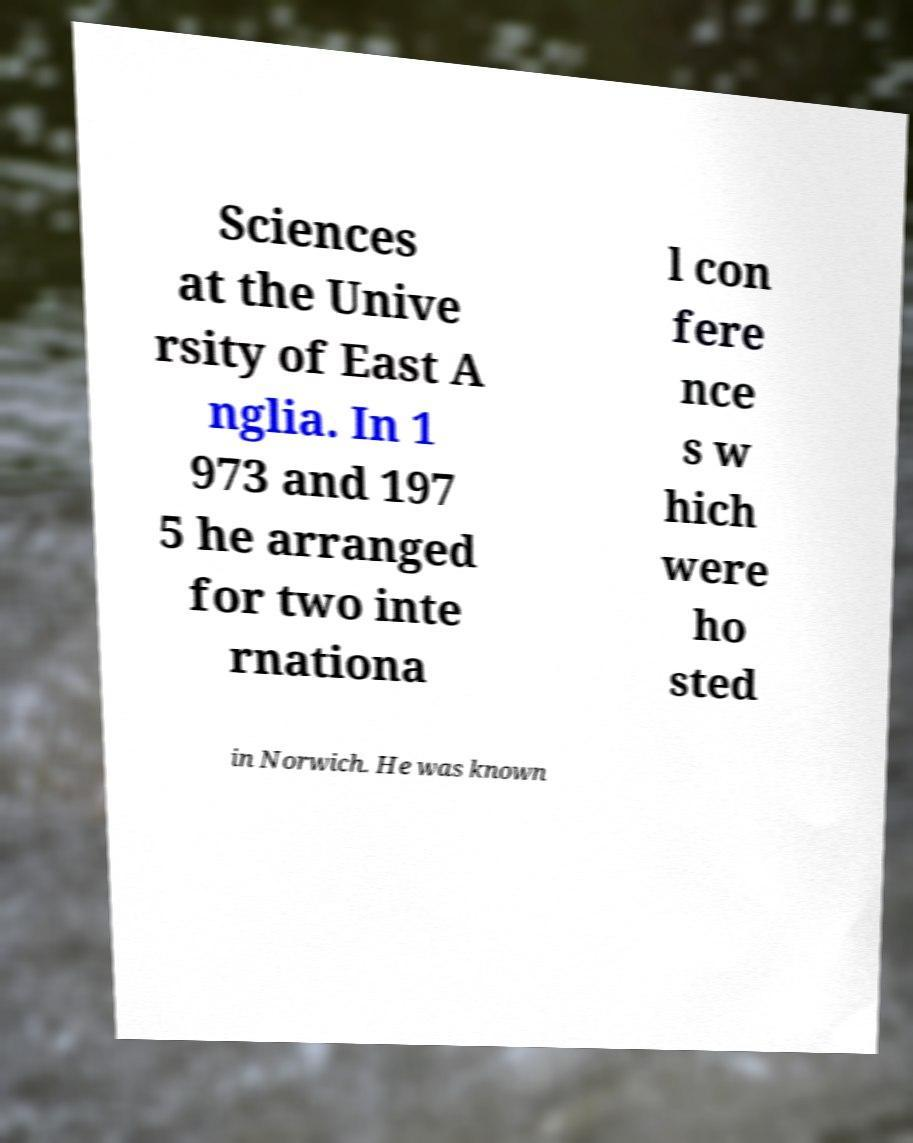What messages or text are displayed in this image? I need them in a readable, typed format. Sciences at the Unive rsity of East A nglia. In 1 973 and 197 5 he arranged for two inte rnationa l con fere nce s w hich were ho sted in Norwich. He was known 